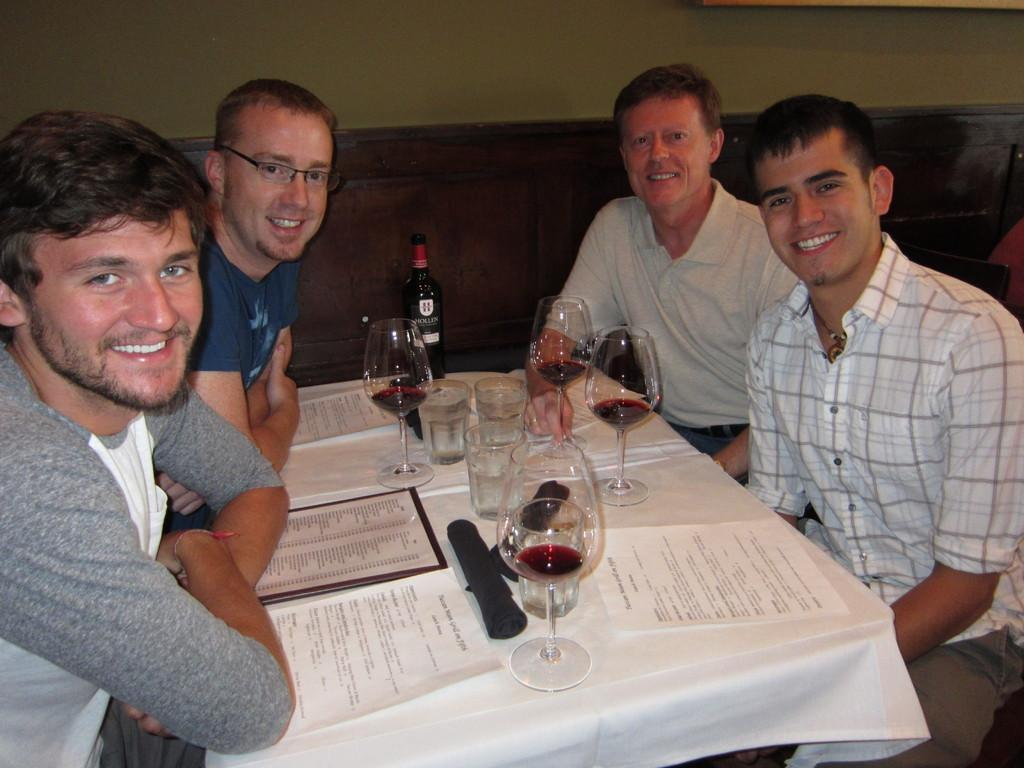How many people are present in the image? There are four people in the image. What are the people doing in the image? The people are sitting in front of a table. What objects can be seen on the table? There are glasses and papers on the table. What type of stem is visible on the table in the image? There is no stem present on the table in the image. Can you see a duck in the image? There is no duck present in the image. 